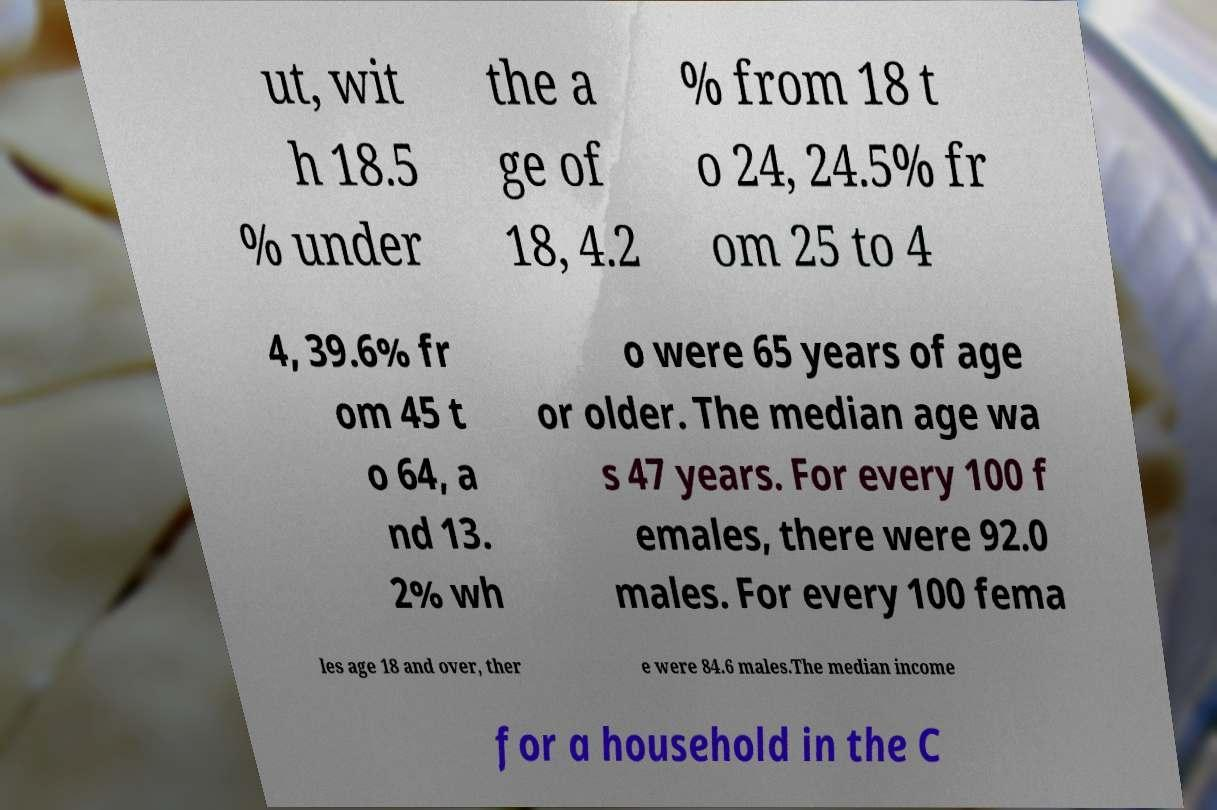I need the written content from this picture converted into text. Can you do that? ut, wit h 18.5 % under the a ge of 18, 4.2 % from 18 t o 24, 24.5% fr om 25 to 4 4, 39.6% fr om 45 t o 64, a nd 13. 2% wh o were 65 years of age or older. The median age wa s 47 years. For every 100 f emales, there were 92.0 males. For every 100 fema les age 18 and over, ther e were 84.6 males.The median income for a household in the C 